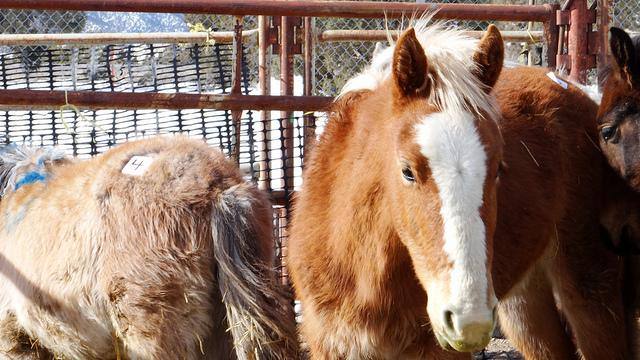What kind of races does this animal run?

Choices:
A) car
B) three legged
C) derby
D) plane derby 